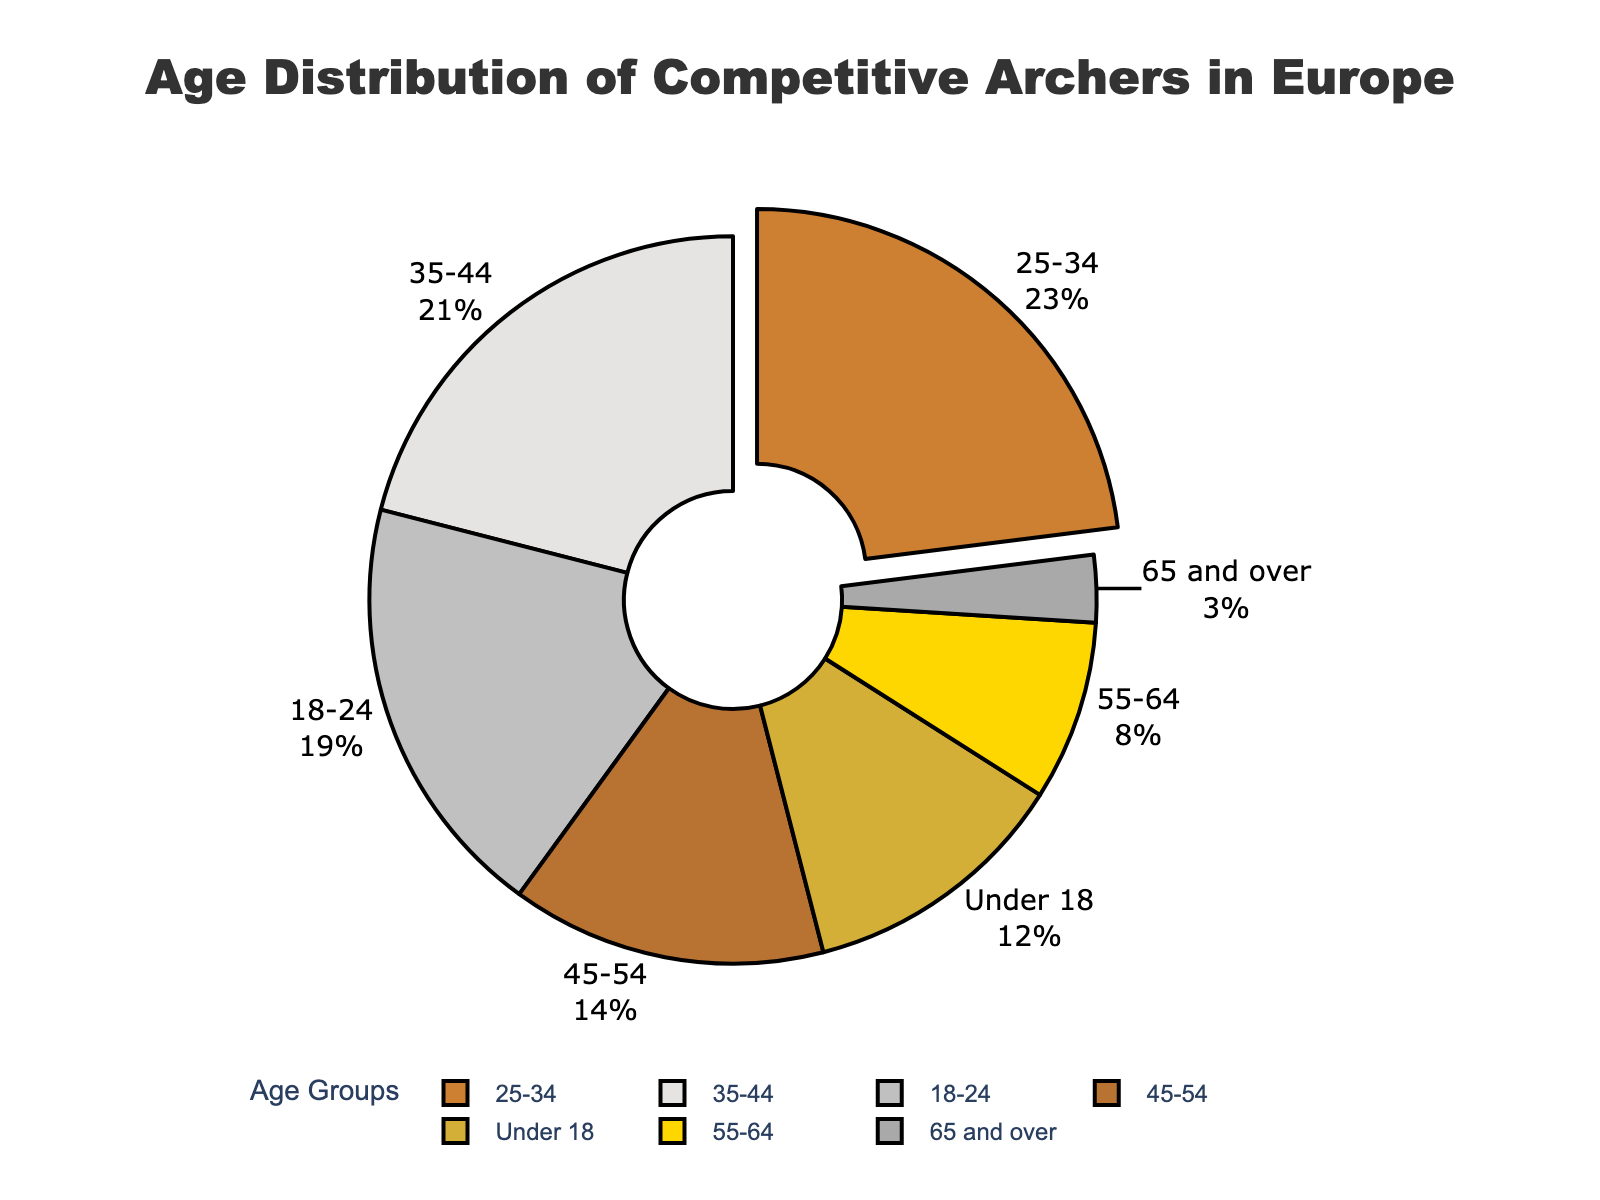What's the largest age group of competitive archers in Europe? Identify the slice from the pie chart that has been pulled out, which also has the highest percentage label.
Answer: 25-34 Which age group has the smallest percentage? Look for the smallest slice and check its label for the percentage.
Answer: 65 and over How much larger is the percentage of archers aged 25-34 compared to those aged 55-64? Subtract the percentage of the 55-64 age group from the percentage of the 25-34 age group: 23 - 8 = 15%.
Answer: 15% What is the sum of the percentages of archers in the 18-24 and 35-44 age groups? Add the two percentages: 19% for 18-24 and 21% for 35-44, which equals 40%.
Answer: 40% Which age groups have a percentage greater than 20%? Identify slices larger than 20% by checking their labels.
Answer: 25-34, 35-44 Is the percentage of archers aged 35-44 more or less than that of those aged under 18? Compare the percentages: 21% (35-44) versus 12% (under 18). Clearly, 21% is more.
Answer: More What are the combined percentages of archers under 18 and archers aged 65 and over? Add 12% (under 18) to 3% (65 and over): 12 + 3 = 15%.
Answer: 15% How does the percentage of archers aged 45-54 compare to the percentage of those aged 55-64? Compare the labels: 14% for 45-54 is greater than 8% for 55-64.
Answer: Greater What is the average percentage of archers in the 25-34, 35-44, and 45-54 age groups? Add the percentages: 23% + 21% + 14% = 58%. Divide by 3: 58% / 3 = 19.33%.
Answer: 19.33% How many age groups have a percentage less than 10%? Identify and count the slices with less than 10%: 8% (55-64) and 3% (65 and over), making a total of 2 groups.
Answer: 2 